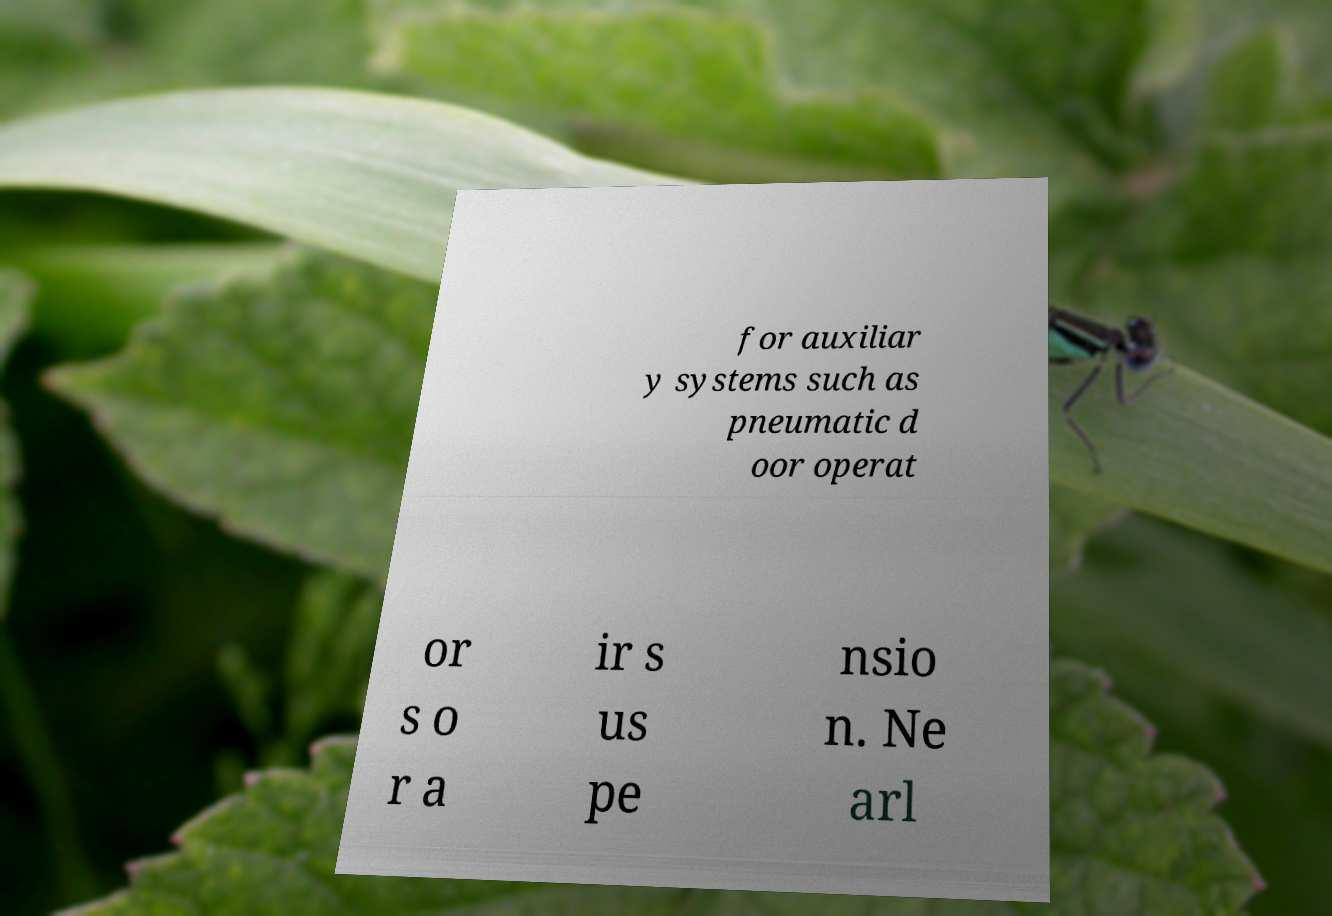I need the written content from this picture converted into text. Can you do that? for auxiliar y systems such as pneumatic d oor operat or s o r a ir s us pe nsio n. Ne arl 